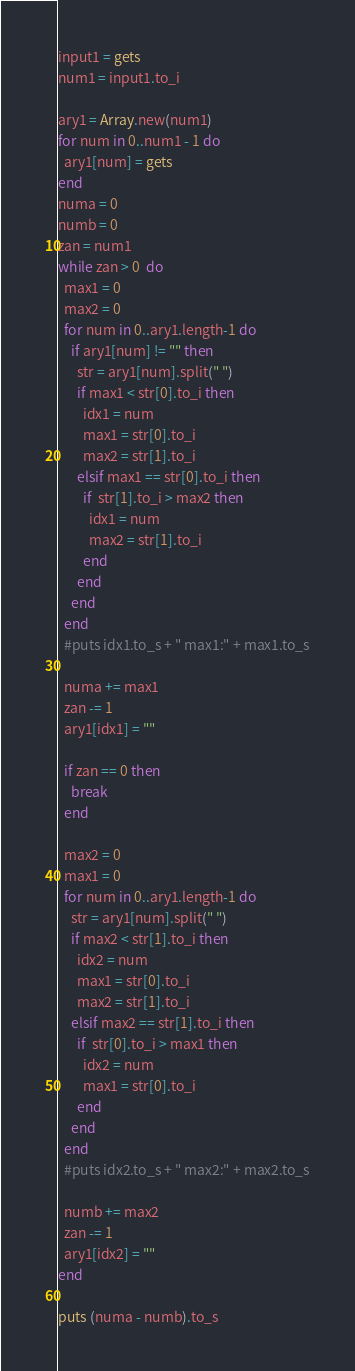Convert code to text. <code><loc_0><loc_0><loc_500><loc_500><_Ruby_>input1 = gets
num1 = input1.to_i

ary1 = Array.new(num1)
for num in 0..num1 - 1 do
  ary1[num] = gets
end 
numa = 0
numb = 0
zan = num1
while zan > 0  do
  max1 = 0
  max2 = 0
  for num in 0..ary1.length-1 do
    if ary1[num] != "" then
      str = ary1[num].split(" ")
      if max1 < str[0].to_i then
        idx1 = num
        max1 = str[0].to_i
        max2 = str[1].to_i
      elsif max1 == str[0].to_i then
        if  str[1].to_i > max2 then
          idx1 = num
          max2 = str[1].to_i
        end
      end
    end
  end 
  #puts idx1.to_s + " max1:" + max1.to_s

  numa += max1
  zan -= 1
  ary1[idx1] = ""

  if zan == 0 then
    break
  end

  max2 = 0
  max1 = 0
  for num in 0..ary1.length-1 do
    str = ary1[num].split(" ")
    if max2 < str[1].to_i then
      idx2 = num
      max1 = str[0].to_i
      max2 = str[1].to_i
    elsif max2 == str[1].to_i then
      if  str[0].to_i > max1 then
        idx2 = num
        max1 = str[0].to_i
      end
    end
  end 
  #puts idx2.to_s + " max2:" + max2.to_s

  numb += max2
  zan -= 1
  ary1[idx2] = ""
end

puts (numa - numb).to_s
</code> 